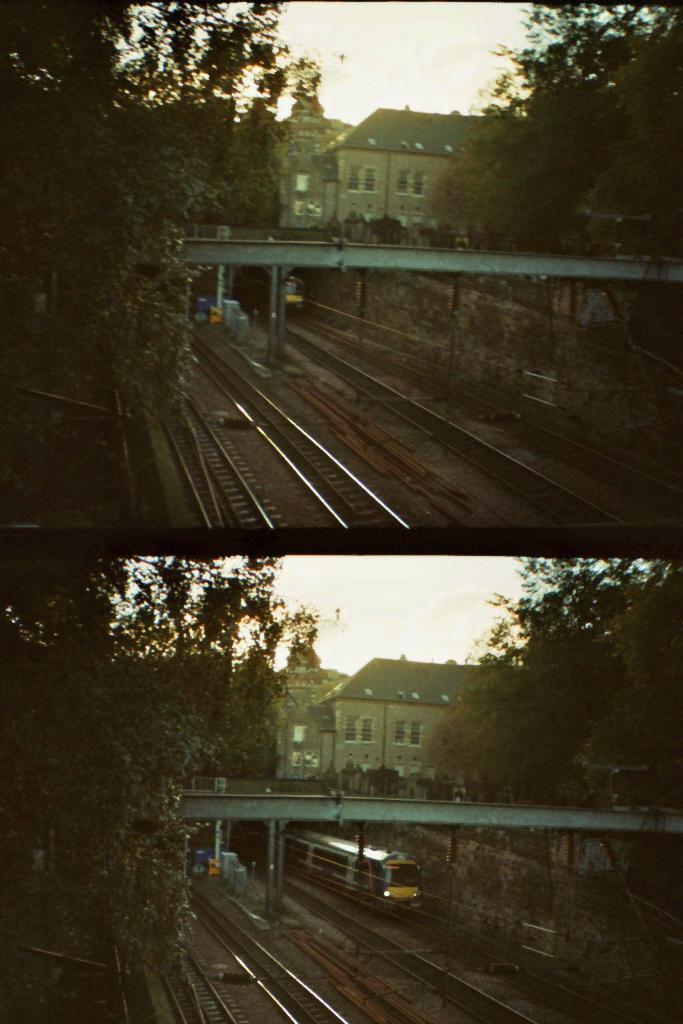Can you describe this image briefly? This is a collage image. In this image I can see buildings, railway tracks, trees, a train on a railway track and some other objects. In the background I can see the sky. 